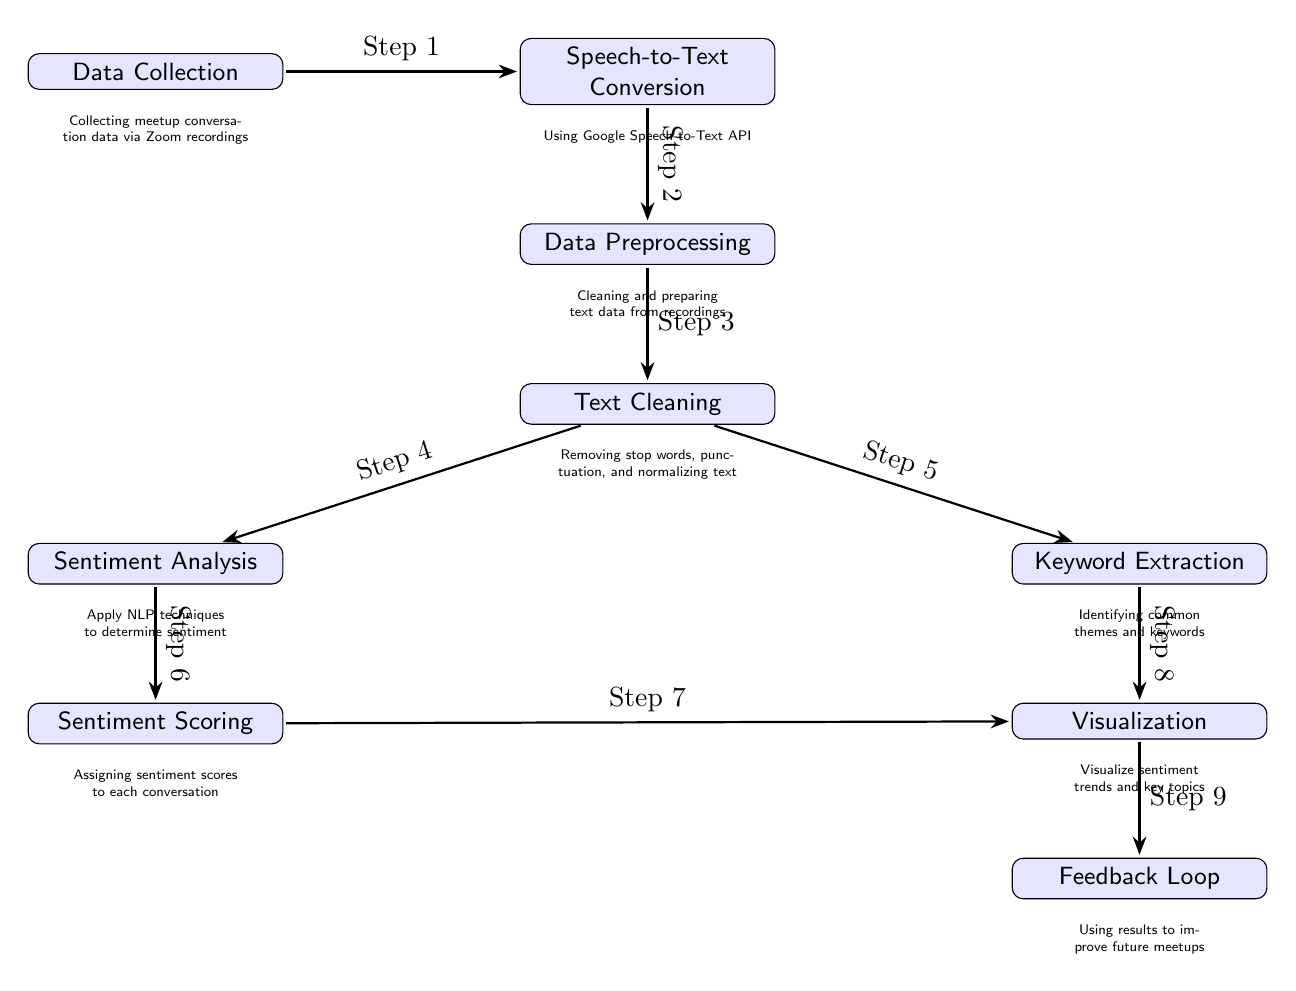What is the first step in the diagram? The first step in the diagram is labeled as "Step 1" which corresponds to the node "Data Collection". This is confirmed by the labels indicating the process flow.
Answer: Data Collection What type of conversion is performed after data collection? Following "Data Collection", the next node indicates "Speech-to-Text Conversion". This is derived from the arrow flowing from "Data Collection" to "Speech-to-Text Conversion".
Answer: Speech-to-Text Conversion How many steps are included in the diagram? There are a total of nine nodes connected by arrows representing steps from the beginning to the end of the process. By counting all the box nodes in the diagram, the total is determined.
Answer: Nine Which two processes occur simultaneously after text cleaning? After the "Text Cleaning" node, there are two arrows leading to "Sentiment Analysis" and "Keyword Extraction", indicating that these tasks are executed in parallel.
Answer: Sentiment Analysis and Keyword Extraction What is the final step in the process? The last node of the diagram represents "Feedback Loop", which is indicated by the arrow leading into this node from "Visualization", making it the final process in the flow.
Answer: Feedback Loop Which step involves assigning scores to sentiments? The step specifically labeled "Sentiment Scoring" directly follows the "Sentiment Analysis" node, which indicates this is where sentiment scores are assigned to the analyzed data.
Answer: Sentiment Scoring How does visualization relate to both sentiment scoring and keyword extraction? "Visualization" is influenced by both "Sentiment Scoring" and "Keyword Extraction", as indicated by the arrows stemming from both nodes directing to "Visualization", showcasing their direct input into this process.
Answer: Both Sentiment Scoring and Keyword Extraction contribute to Visualization What is the purpose of the feedback loop in this diagram? The "Feedback Loop" is utilized to improve future meetups, as indicated directly in the description beneath the node, emphasizing the iterative nature of the analysis for better outcomes.
Answer: Improve future meetups What type of analysis is performed as part of keyword extraction? The specific analysis performed in this process is identifying common themes and keywords from the text data, which allows for better understanding and categorization of the discussions.
Answer: Identifying common themes and keywords 